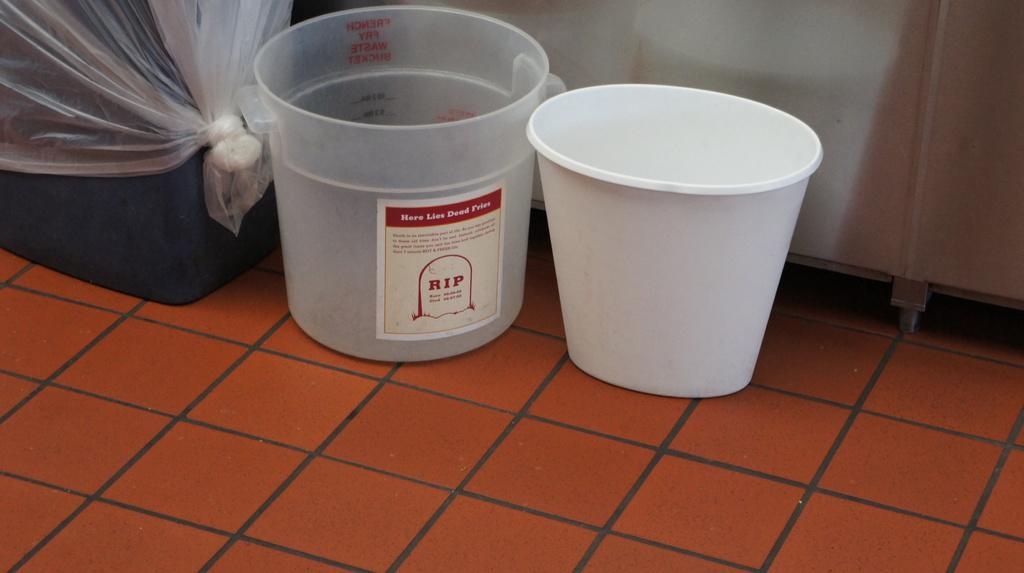<image>
Create a compact narrative representing the image presented. A plastic cup that says 'here lies dead fries' on the ground 